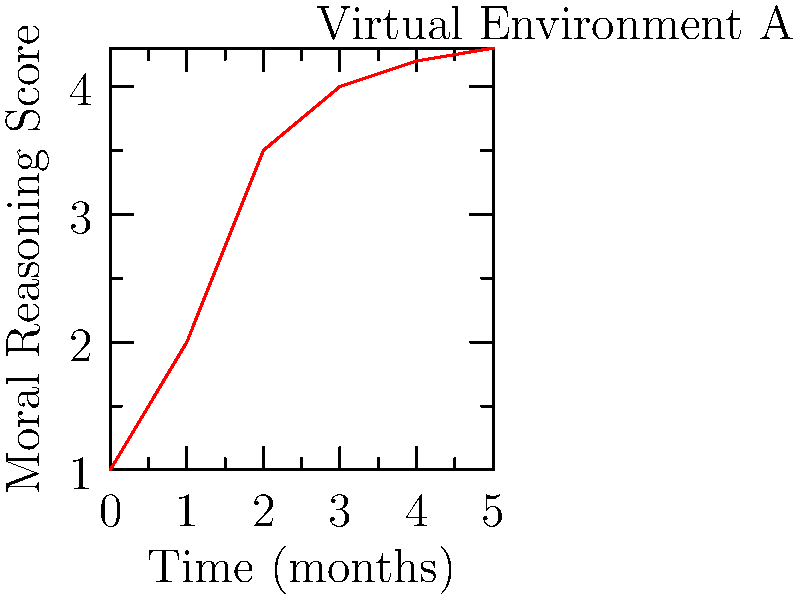Analyze the line graph showing the progression of moral reasoning skills over time in a virtual environment. What is the rate of change in moral reasoning scores between months 1 and 2? To find the rate of change between months 1 and 2, we need to:

1. Identify the moral reasoning scores at months 1 and 2:
   Month 1: $y_1 = 2$
   Month 2: $y_2 = 3.5$

2. Calculate the change in score:
   $\Delta y = y_2 - y_1 = 3.5 - 2 = 1.5$

3. Calculate the change in time:
   $\Delta x = x_2 - x_1 = 2 - 1 = 1$ month

4. Calculate the rate of change:
   Rate of change = $\frac{\Delta y}{\Delta x} = \frac{1.5}{1} = 1.5$

Therefore, the rate of change in moral reasoning scores between months 1 and 2 is 1.5 points per month.
Answer: 1.5 points/month 